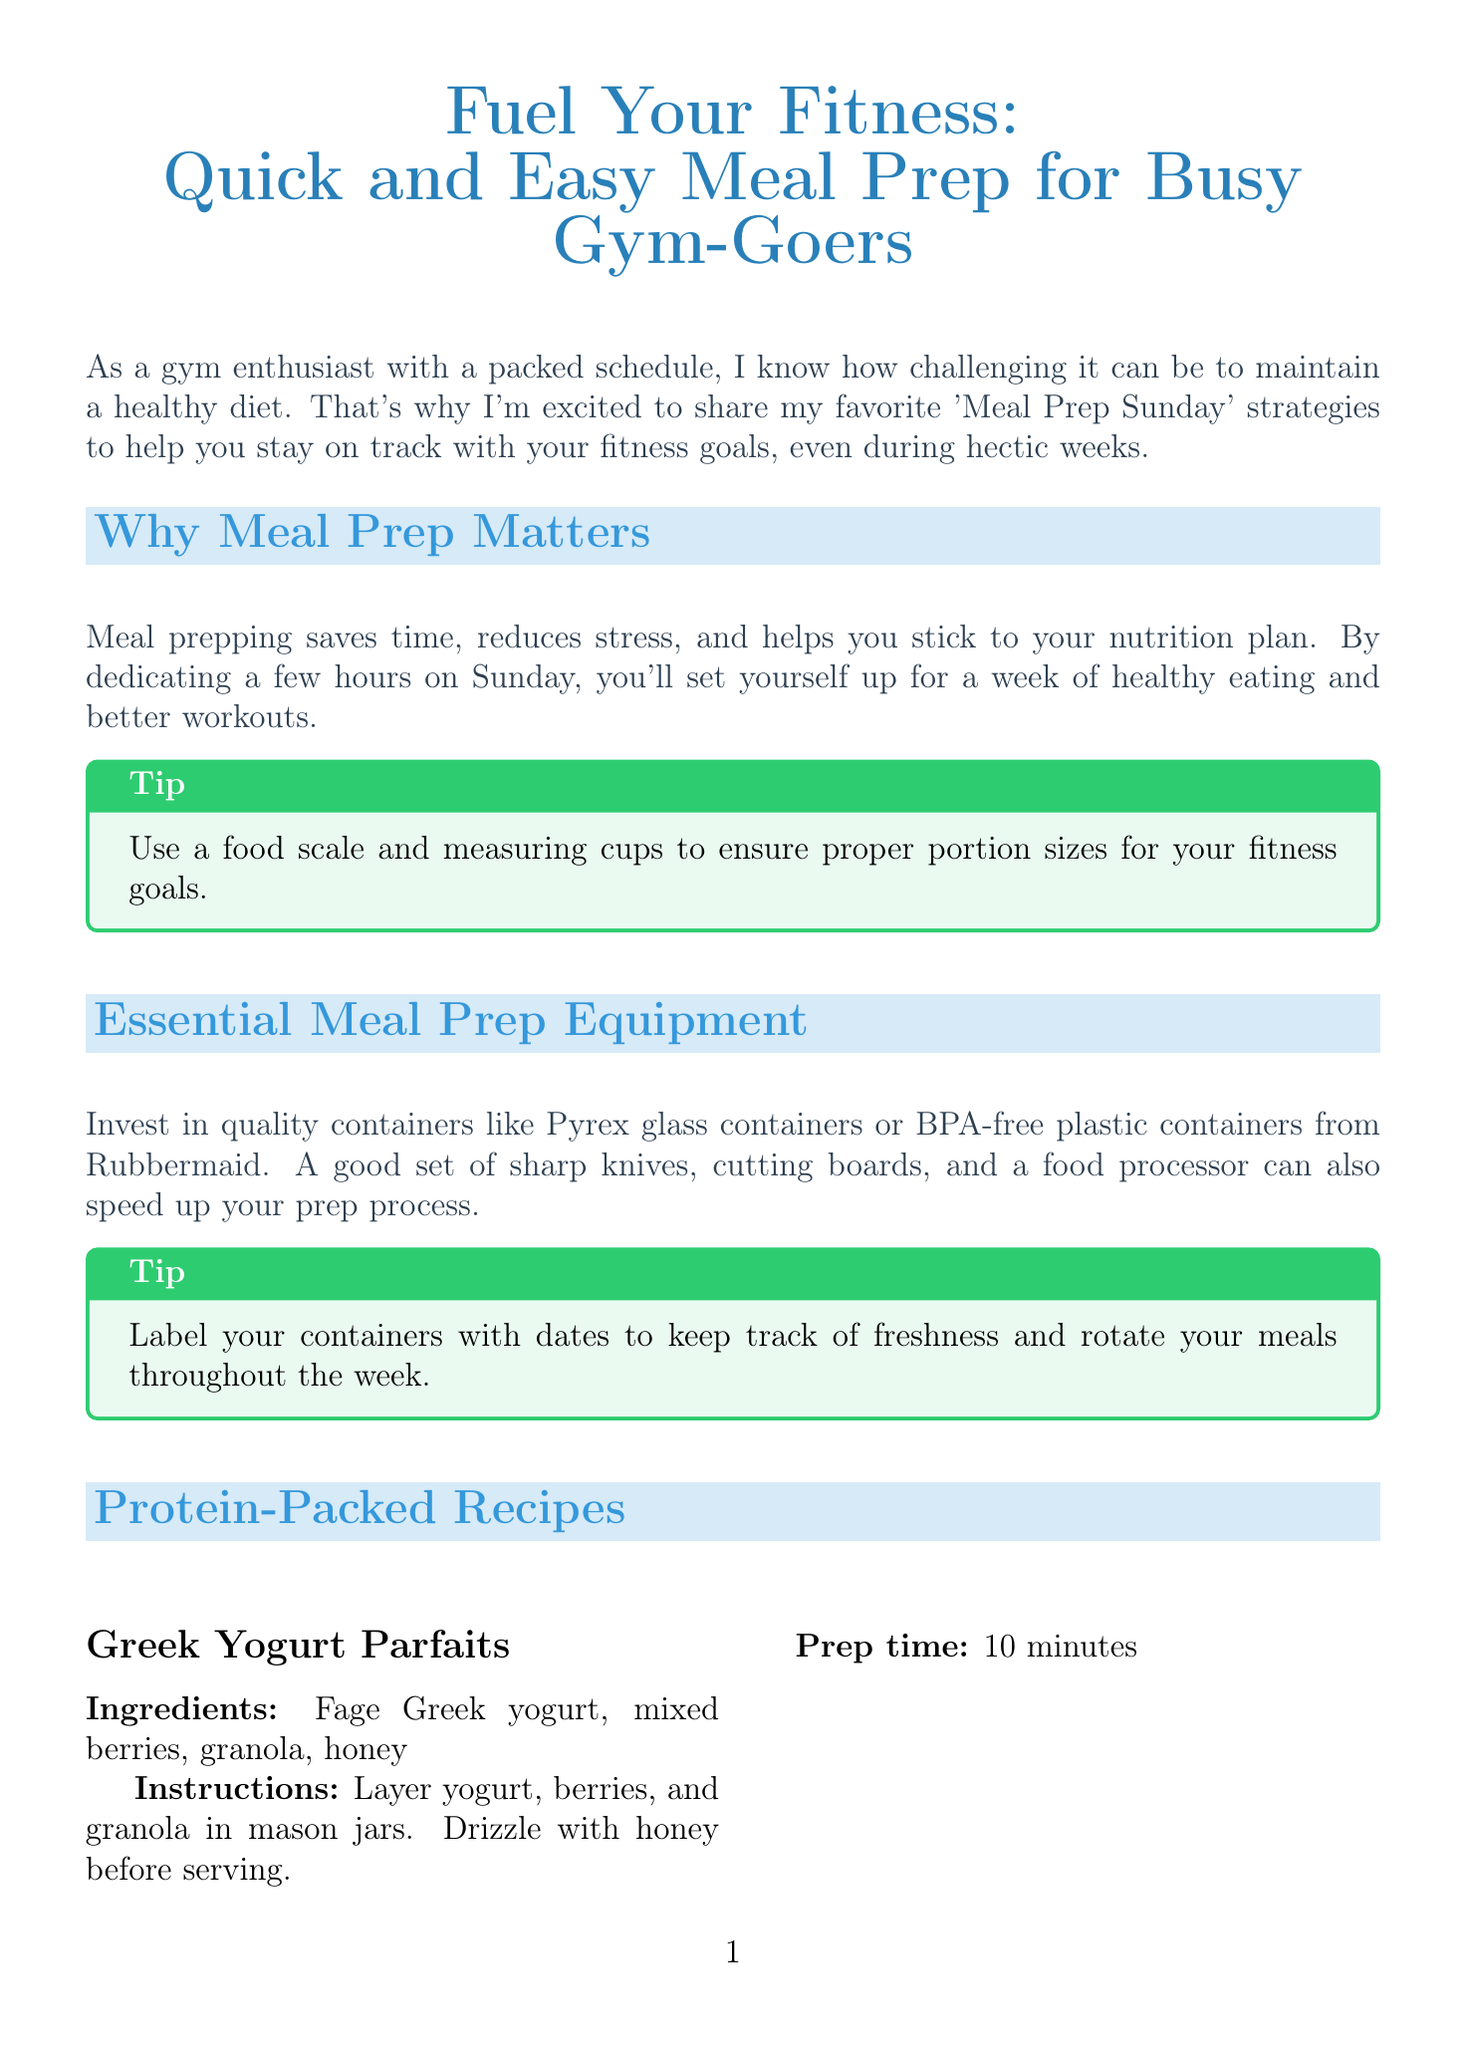What is the title of the newsletter? The title of the newsletter is prominently displayed at the beginning of the document.
Answer: Fuel Your Fitness: Quick and Easy Meal Prep for Busy Gym-Goers How long does it take to prepare Greek Yogurt Parfaits? The prep time for Greek Yogurt Parfaits is stated in the recipes section of the document.
Answer: 10 minutes What is one essential piece of meal prep equipment mentioned? The document lists essential equipment for meal prep.
Answer: Pyrex glass containers Name one of the protein-packed recipes included. The document mentions specific recipes within the Protein-Packed Recipes section.
Answer: Grilled Chicken and Veggie Bowls What is a recommended hydration beverage prep method? The document provides suggestions for beverage preparation in the Hydration Station section.
Answer: Infuse water with cucumber What is the main reason to practice meal prepping? The document explains the benefits of meal prepping.
Answer: Saves time How can you make snacks more accessible? The document provides a tip for snack organization for easy access.
Answer: Pre-portion snacks into small containers What type of meal can help minimize cleanup? The document suggests meal types that facilitate easier cooking processes.
Answer: Sheet pan meals What should you do with your containers to track freshness? The document provides a tip related to container management.
Answer: Label your containers with dates 